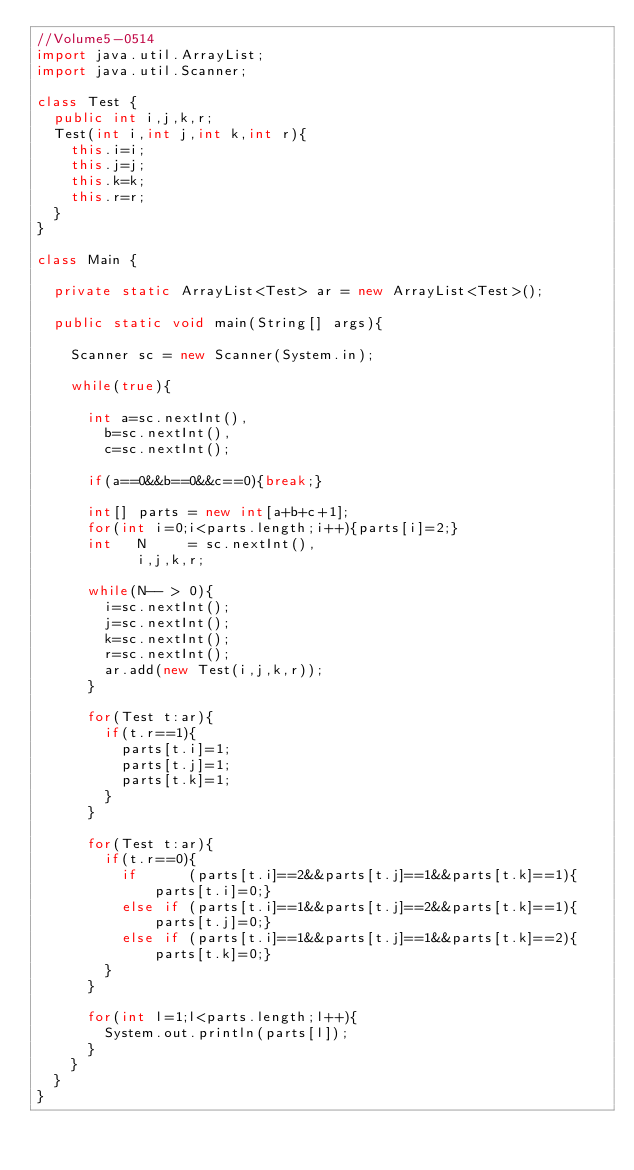Convert code to text. <code><loc_0><loc_0><loc_500><loc_500><_Java_>//Volume5-0514
import java.util.ArrayList;
import java.util.Scanner;

class Test {
	public int i,j,k,r;
	Test(int i,int j,int k,int r){
		this.i=i;
		this.j=j;
		this.k=k;
		this.r=r;
	}
}

class Main {

	private static ArrayList<Test> ar = new ArrayList<Test>();

	public static void main(String[] args){

		Scanner sc = new Scanner(System.in);

		while(true){

			int a=sc.nextInt(),
				b=sc.nextInt(),
				c=sc.nextInt();

			if(a==0&&b==0&&c==0){break;}

			int[] parts = new int[a+b+c+1];
			for(int i=0;i<parts.length;i++){parts[i]=2;}
			int   N     = sc.nextInt(),
			      i,j,k,r;

			while(N-- > 0){
				i=sc.nextInt();
				j=sc.nextInt();
				k=sc.nextInt();
				r=sc.nextInt();
				ar.add(new Test(i,j,k,r));
			}

			for(Test t:ar){
				if(t.r==1){
					parts[t.i]=1;
					parts[t.j]=1;
					parts[t.k]=1;
				}
			}

			for(Test t:ar){
				if(t.r==0){
					if      (parts[t.i]==2&&parts[t.j]==1&&parts[t.k]==1){parts[t.i]=0;}
					else if (parts[t.i]==1&&parts[t.j]==2&&parts[t.k]==1){parts[t.j]=0;}
					else if (parts[t.i]==1&&parts[t.j]==1&&parts[t.k]==2){parts[t.k]=0;}
				}
			}

			for(int l=1;l<parts.length;l++){
				System.out.println(parts[l]);
			}
		}
	}
}</code> 